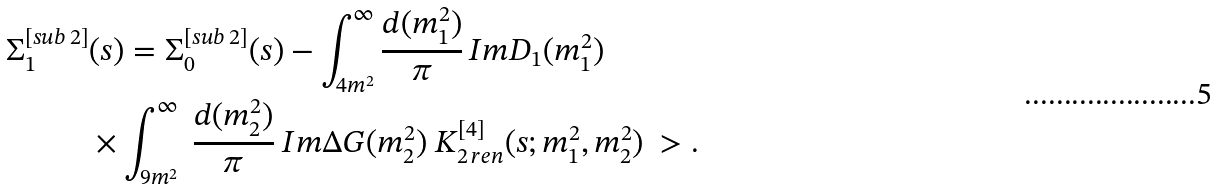Convert formula to latex. <formula><loc_0><loc_0><loc_500><loc_500>\Sigma ^ { [ s u b \, 2 ] } _ { 1 } & ( s ) = \Sigma ^ { [ s u b \, 2 ] } _ { 0 } ( s ) - \int _ { 4 m ^ { 2 } } ^ { \infty } \frac { d ( m _ { 1 } ^ { 2 } ) } { \pi } \, I m D _ { 1 } ( m _ { 1 } ^ { 2 } ) \\ & \times \int _ { 9 m ^ { 2 } } ^ { \infty } \ \frac { d ( m _ { 2 } ^ { 2 } ) } { \pi } \ I m \Delta G ( m _ { 2 } ^ { 2 } ) \ K ^ { [ 4 ] } _ { 2 \, r e n } ( s ; m _ { 1 } ^ { 2 } , m _ { 2 } ^ { 2 } ) \ > .</formula> 